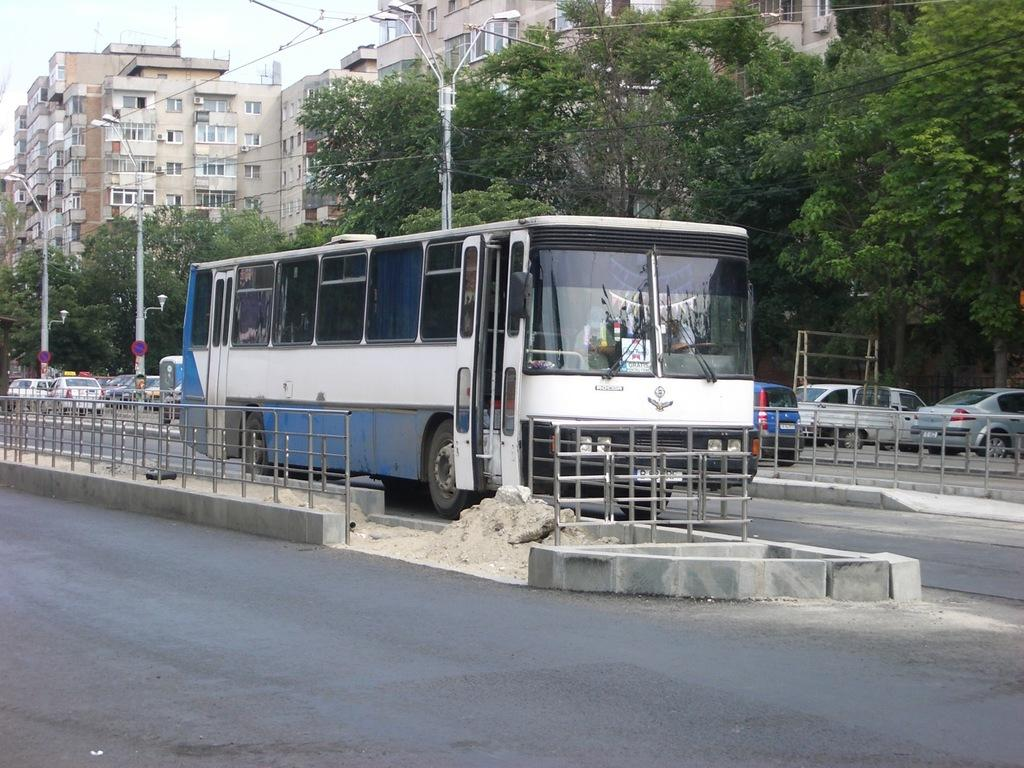What is the main mode of transportation in the image? There is a bus in the image, which is a mode of transportation. What type of barrier can be seen in the image? There are fences in the image. What type of terrain is visible in the image? Sand is visible in the image. What type of pathways are present in the image? There are roads in the image. What type of vehicles are present in the image? Cars are present in the image. What type of infrastructure is visible in the image? Electric poles are in the image. What type of signage is visible in the image? Sign boards are visible in the image. What type of vegetation is present in the image? Trees are present in the image. What type of structures are visible in the image? There are buildings with windows in the image. What type of miscellaneous objects are present in the image? There are various objects in the image. What can be seen in the background of the image? The sky is visible in the background of the image. How many oranges are hanging from the electric poles in the image? There are no oranges present in the image, as it features a bus, fences, sand, roads, cars, electric poles, sign boards, trees, buildings, and various objects, but no oranges. Is there a hose connected to the bus in the image? There is no hose connected to the bus in the image. 